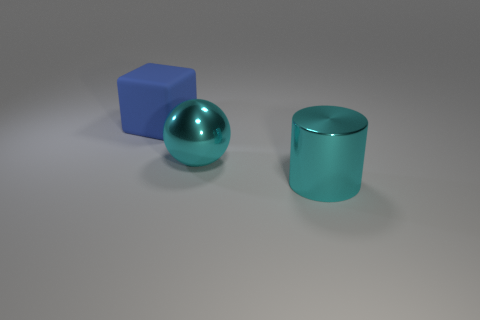Is the matte block the same color as the big shiny cylinder?
Your response must be concise. No. Is the shape of the large metal thing that is right of the shiny ball the same as  the matte object?
Keep it short and to the point. No. How many objects are behind the large cyan shiny sphere and in front of the large blue cube?
Give a very brief answer. 0. What is the material of the large cyan cylinder?
Make the answer very short. Metal. Is there anything else that has the same color as the large rubber cube?
Offer a terse response. No. Do the sphere and the blue block have the same material?
Make the answer very short. No. What number of cyan metallic things are right of the shiny object on the right side of the cyan thing behind the metallic cylinder?
Make the answer very short. 0. What number of large metal things are there?
Your answer should be compact. 2. Are there fewer shiny spheres in front of the metallic cylinder than rubber objects that are in front of the cyan sphere?
Keep it short and to the point. No. Is the number of cyan balls that are to the right of the big cyan cylinder less than the number of big cylinders?
Offer a terse response. Yes. 